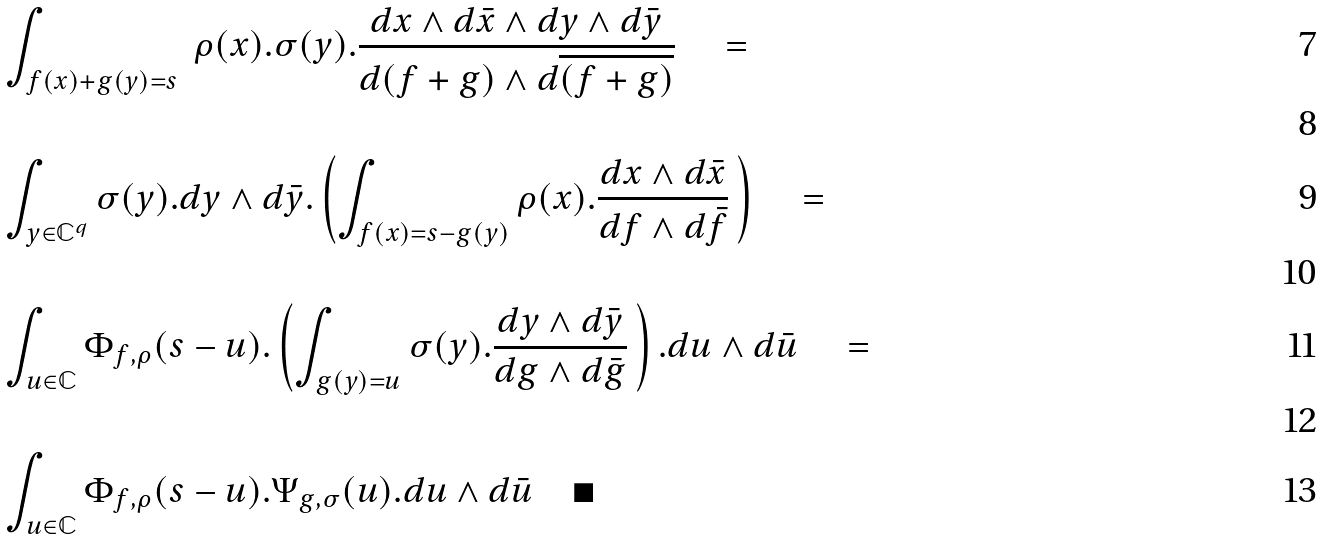Convert formula to latex. <formula><loc_0><loc_0><loc_500><loc_500>& \int _ { f ( x ) + g ( y ) = s } \ \rho ( x ) . \sigma ( y ) . \frac { d x \wedge d \bar { x } \wedge d y \wedge d \bar { y } } { d ( f + g ) \wedge d \overline { ( f + g ) } } \quad = \\ & \quad \\ & \int _ { y \in \mathbb { C } ^ { q } } \sigma ( y ) . d y \wedge d \bar { y } . \left ( \int _ { f ( x ) = s - g ( y ) } \rho ( x ) . \frac { d x \wedge d \bar { x } } { d f \wedge d \bar { f } } \, \right ) \quad = \\ & \quad \\ & \int _ { u \in \mathbb { C } } \Phi _ { f , \rho } ( s - u ) . \left ( \int _ { g ( y ) = u } \sigma ( y ) . \frac { d y \wedge d \bar { y } } { d g \wedge d \bar { g } } \, \right ) . d u \wedge d \bar { u } \quad = \\ & \quad \\ & \int _ { u \in \mathbb { C } } \Phi _ { f , \rho } ( s - u ) . \Psi _ { g , \sigma } ( u ) . d u \wedge d \bar { u } \quad \blacksquare</formula> 